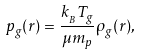<formula> <loc_0><loc_0><loc_500><loc_500>p _ { g } ( r ) = \frac { k _ { _ { B } } T _ { g } } { \mu m _ { p } } \rho _ { g } ( r ) ,</formula> 